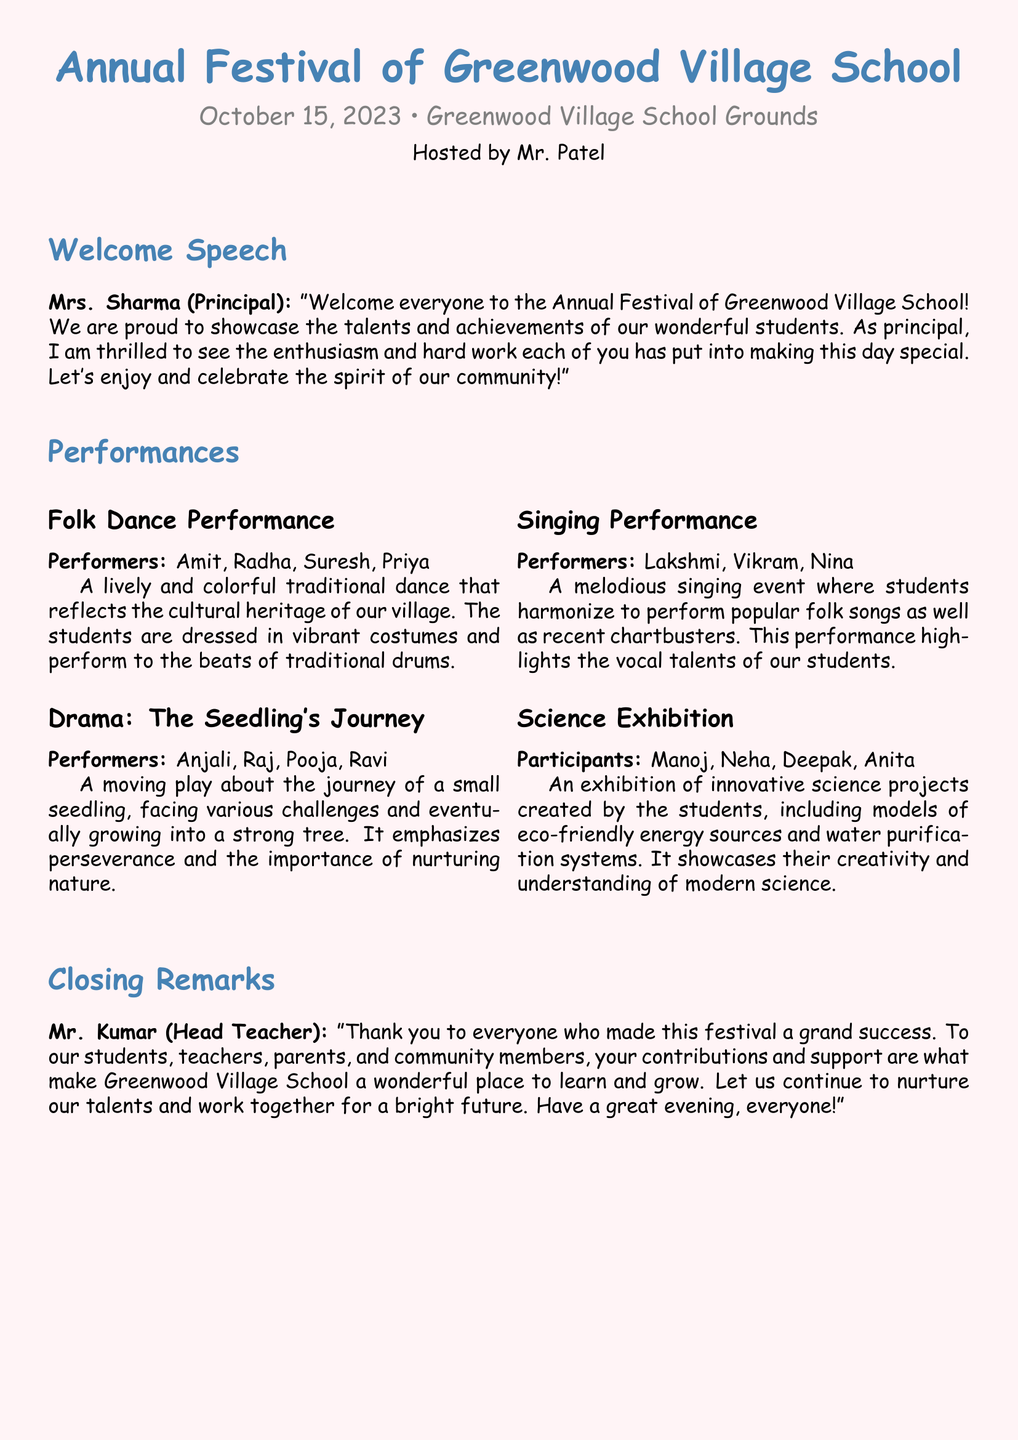What is the date of the festival? The date of the festival is mentioned in the document as October 15, 2023.
Answer: October 15, 2023 Who hosted the festival? The document states that Mr. Patel hosted the festival.
Answer: Mr. Patel Which performance featured a moving play? The document describes "The Seedling's Journey" as a moving play performed by specific students.
Answer: The Seedling's Journey What is one of the themes of the drama performed? The document mentions that the drama emphasizes perseverance and nurturing nature.
Answer: Perseverance How many performers participated in the Folk Dance? The document lists four performers for the Folk Dance performance.
Answer: Four What type of projects were showcased in the Science Exhibition? The document describes the science projects as eco-friendly energy sources and water purification systems.
Answer: Eco-friendly energy sources and water purification systems Who gave the closing remarks? The document states that Mr. Kumar, the Head Teacher, gave the closing remarks.
Answer: Mr. Kumar What was the name of the singing performance? The document refers to the singing event simply as "Singing Performance."
Answer: Singing Performance What is the significance of the festival, according to the Principal? The Principal emphasizes showcasing talents and achievements as significant to the festival.
Answer: Showcasing talents and achievements 